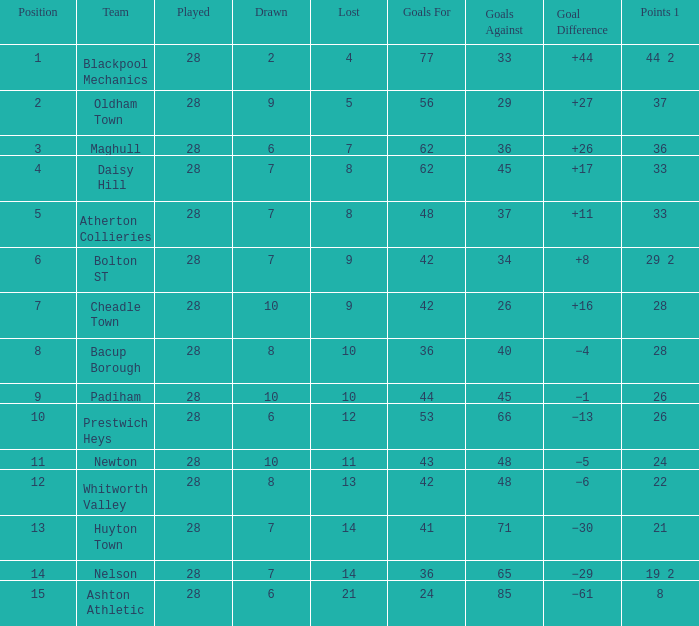For entries with fewer than 28 played, with 45 goals against and points 1 of 33, what is the average drawn? None. 